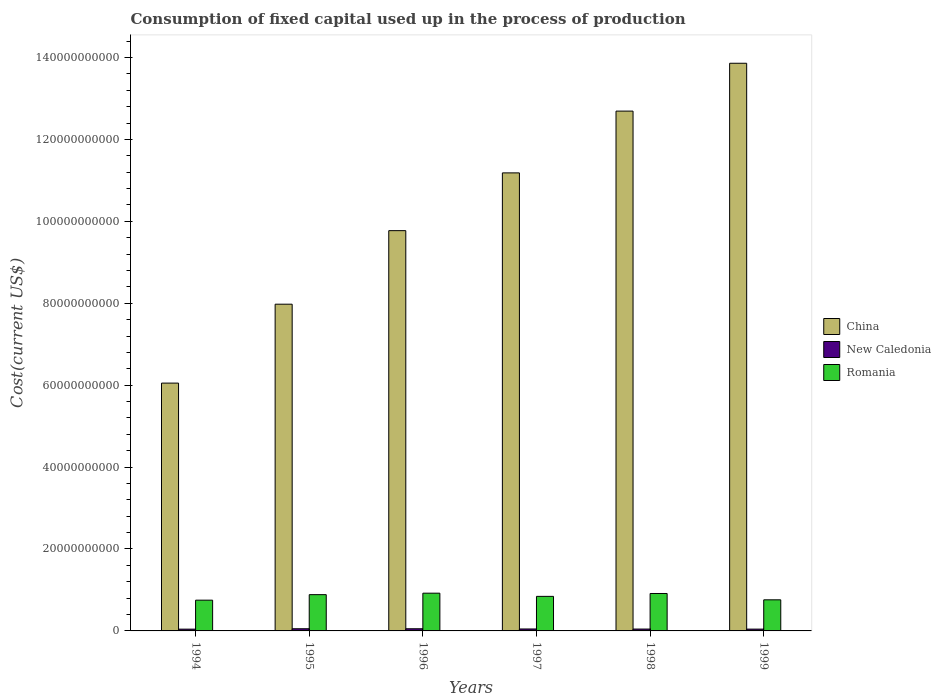How many different coloured bars are there?
Ensure brevity in your answer.  3. Are the number of bars per tick equal to the number of legend labels?
Offer a terse response. Yes. What is the label of the 5th group of bars from the left?
Your answer should be very brief. 1998. What is the amount consumed in the process of production in Romania in 1997?
Your response must be concise. 8.44e+09. Across all years, what is the maximum amount consumed in the process of production in China?
Offer a very short reply. 1.39e+11. Across all years, what is the minimum amount consumed in the process of production in Romania?
Provide a short and direct response. 7.51e+09. What is the total amount consumed in the process of production in Romania in the graph?
Your answer should be compact. 5.07e+1. What is the difference between the amount consumed in the process of production in Romania in 1997 and that in 1998?
Keep it short and to the point. -7.02e+08. What is the difference between the amount consumed in the process of production in New Caledonia in 1997 and the amount consumed in the process of production in China in 1994?
Ensure brevity in your answer.  -6.00e+1. What is the average amount consumed in the process of production in New Caledonia per year?
Offer a terse response. 4.77e+08. In the year 1997, what is the difference between the amount consumed in the process of production in New Caledonia and amount consumed in the process of production in China?
Your answer should be compact. -1.11e+11. In how many years, is the amount consumed in the process of production in New Caledonia greater than 136000000000 US$?
Your response must be concise. 0. What is the ratio of the amount consumed in the process of production in New Caledonia in 1994 to that in 1995?
Your answer should be compact. 0.82. Is the amount consumed in the process of production in China in 1995 less than that in 1997?
Ensure brevity in your answer.  Yes. Is the difference between the amount consumed in the process of production in New Caledonia in 1994 and 1999 greater than the difference between the amount consumed in the process of production in China in 1994 and 1999?
Your answer should be compact. Yes. What is the difference between the highest and the second highest amount consumed in the process of production in New Caledonia?
Ensure brevity in your answer.  3.48e+06. What is the difference between the highest and the lowest amount consumed in the process of production in New Caledonia?
Offer a very short reply. 9.66e+07. In how many years, is the amount consumed in the process of production in Romania greater than the average amount consumed in the process of production in Romania taken over all years?
Your answer should be very brief. 3. Is the sum of the amount consumed in the process of production in New Caledonia in 1995 and 1996 greater than the maximum amount consumed in the process of production in Romania across all years?
Provide a succinct answer. No. What does the 2nd bar from the left in 1996 represents?
Provide a short and direct response. New Caledonia. What does the 1st bar from the right in 1999 represents?
Offer a terse response. Romania. Are all the bars in the graph horizontal?
Give a very brief answer. No. How many years are there in the graph?
Give a very brief answer. 6. Are the values on the major ticks of Y-axis written in scientific E-notation?
Provide a succinct answer. No. Does the graph contain any zero values?
Your answer should be very brief. No. Does the graph contain grids?
Keep it short and to the point. No. How are the legend labels stacked?
Keep it short and to the point. Vertical. What is the title of the graph?
Keep it short and to the point. Consumption of fixed capital used up in the process of production. Does "High income" appear as one of the legend labels in the graph?
Make the answer very short. No. What is the label or title of the Y-axis?
Your response must be concise. Cost(current US$). What is the Cost(current US$) in China in 1994?
Make the answer very short. 6.05e+1. What is the Cost(current US$) of New Caledonia in 1994?
Your response must be concise. 4.34e+08. What is the Cost(current US$) of Romania in 1994?
Make the answer very short. 7.51e+09. What is the Cost(current US$) of China in 1995?
Keep it short and to the point. 7.98e+1. What is the Cost(current US$) of New Caledonia in 1995?
Make the answer very short. 5.31e+08. What is the Cost(current US$) in Romania in 1995?
Make the answer very short. 8.86e+09. What is the Cost(current US$) of China in 1996?
Your answer should be very brief. 9.77e+1. What is the Cost(current US$) in New Caledonia in 1996?
Your response must be concise. 5.27e+08. What is the Cost(current US$) of Romania in 1996?
Ensure brevity in your answer.  9.21e+09. What is the Cost(current US$) of China in 1997?
Your answer should be compact. 1.12e+11. What is the Cost(current US$) of New Caledonia in 1997?
Keep it short and to the point. 4.77e+08. What is the Cost(current US$) in Romania in 1997?
Provide a succinct answer. 8.44e+09. What is the Cost(current US$) of China in 1998?
Give a very brief answer. 1.27e+11. What is the Cost(current US$) in New Caledonia in 1998?
Provide a short and direct response. 4.55e+08. What is the Cost(current US$) in Romania in 1998?
Ensure brevity in your answer.  9.14e+09. What is the Cost(current US$) in China in 1999?
Your response must be concise. 1.39e+11. What is the Cost(current US$) of New Caledonia in 1999?
Your response must be concise. 4.39e+08. What is the Cost(current US$) in Romania in 1999?
Make the answer very short. 7.59e+09. Across all years, what is the maximum Cost(current US$) of China?
Your response must be concise. 1.39e+11. Across all years, what is the maximum Cost(current US$) of New Caledonia?
Your response must be concise. 5.31e+08. Across all years, what is the maximum Cost(current US$) of Romania?
Provide a succinct answer. 9.21e+09. Across all years, what is the minimum Cost(current US$) in China?
Your answer should be very brief. 6.05e+1. Across all years, what is the minimum Cost(current US$) of New Caledonia?
Make the answer very short. 4.34e+08. Across all years, what is the minimum Cost(current US$) in Romania?
Ensure brevity in your answer.  7.51e+09. What is the total Cost(current US$) in China in the graph?
Offer a terse response. 6.15e+11. What is the total Cost(current US$) in New Caledonia in the graph?
Make the answer very short. 2.86e+09. What is the total Cost(current US$) in Romania in the graph?
Offer a terse response. 5.07e+1. What is the difference between the Cost(current US$) of China in 1994 and that in 1995?
Your answer should be compact. -1.93e+1. What is the difference between the Cost(current US$) of New Caledonia in 1994 and that in 1995?
Your answer should be compact. -9.66e+07. What is the difference between the Cost(current US$) of Romania in 1994 and that in 1995?
Your answer should be very brief. -1.35e+09. What is the difference between the Cost(current US$) of China in 1994 and that in 1996?
Provide a succinct answer. -3.72e+1. What is the difference between the Cost(current US$) in New Caledonia in 1994 and that in 1996?
Provide a short and direct response. -9.32e+07. What is the difference between the Cost(current US$) of Romania in 1994 and that in 1996?
Offer a very short reply. -1.70e+09. What is the difference between the Cost(current US$) of China in 1994 and that in 1997?
Provide a succinct answer. -5.13e+1. What is the difference between the Cost(current US$) in New Caledonia in 1994 and that in 1997?
Give a very brief answer. -4.23e+07. What is the difference between the Cost(current US$) in Romania in 1994 and that in 1997?
Ensure brevity in your answer.  -9.27e+08. What is the difference between the Cost(current US$) of China in 1994 and that in 1998?
Offer a very short reply. -6.64e+1. What is the difference between the Cost(current US$) of New Caledonia in 1994 and that in 1998?
Make the answer very short. -2.11e+07. What is the difference between the Cost(current US$) of Romania in 1994 and that in 1998?
Your answer should be compact. -1.63e+09. What is the difference between the Cost(current US$) of China in 1994 and that in 1999?
Your answer should be very brief. -7.81e+1. What is the difference between the Cost(current US$) of New Caledonia in 1994 and that in 1999?
Ensure brevity in your answer.  -4.84e+06. What is the difference between the Cost(current US$) in Romania in 1994 and that in 1999?
Provide a succinct answer. -8.38e+07. What is the difference between the Cost(current US$) of China in 1995 and that in 1996?
Provide a succinct answer. -1.80e+1. What is the difference between the Cost(current US$) of New Caledonia in 1995 and that in 1996?
Your answer should be very brief. 3.48e+06. What is the difference between the Cost(current US$) in Romania in 1995 and that in 1996?
Provide a short and direct response. -3.56e+08. What is the difference between the Cost(current US$) of China in 1995 and that in 1997?
Make the answer very short. -3.21e+1. What is the difference between the Cost(current US$) in New Caledonia in 1995 and that in 1997?
Make the answer very short. 5.43e+07. What is the difference between the Cost(current US$) of Romania in 1995 and that in 1997?
Your answer should be compact. 4.20e+08. What is the difference between the Cost(current US$) in China in 1995 and that in 1998?
Keep it short and to the point. -4.71e+1. What is the difference between the Cost(current US$) of New Caledonia in 1995 and that in 1998?
Give a very brief answer. 7.55e+07. What is the difference between the Cost(current US$) of Romania in 1995 and that in 1998?
Your answer should be compact. -2.81e+08. What is the difference between the Cost(current US$) of China in 1995 and that in 1999?
Offer a terse response. -5.88e+1. What is the difference between the Cost(current US$) in New Caledonia in 1995 and that in 1999?
Keep it short and to the point. 9.18e+07. What is the difference between the Cost(current US$) of Romania in 1995 and that in 1999?
Provide a succinct answer. 1.26e+09. What is the difference between the Cost(current US$) in China in 1996 and that in 1997?
Your answer should be compact. -1.41e+1. What is the difference between the Cost(current US$) of New Caledonia in 1996 and that in 1997?
Keep it short and to the point. 5.08e+07. What is the difference between the Cost(current US$) in Romania in 1996 and that in 1997?
Offer a very short reply. 7.76e+08. What is the difference between the Cost(current US$) in China in 1996 and that in 1998?
Your answer should be very brief. -2.92e+1. What is the difference between the Cost(current US$) in New Caledonia in 1996 and that in 1998?
Make the answer very short. 7.21e+07. What is the difference between the Cost(current US$) of Romania in 1996 and that in 1998?
Ensure brevity in your answer.  7.47e+07. What is the difference between the Cost(current US$) of China in 1996 and that in 1999?
Your answer should be very brief. -4.09e+1. What is the difference between the Cost(current US$) in New Caledonia in 1996 and that in 1999?
Offer a terse response. 8.83e+07. What is the difference between the Cost(current US$) of Romania in 1996 and that in 1999?
Your answer should be compact. 1.62e+09. What is the difference between the Cost(current US$) in China in 1997 and that in 1998?
Offer a very short reply. -1.51e+1. What is the difference between the Cost(current US$) in New Caledonia in 1997 and that in 1998?
Give a very brief answer. 2.12e+07. What is the difference between the Cost(current US$) in Romania in 1997 and that in 1998?
Give a very brief answer. -7.02e+08. What is the difference between the Cost(current US$) in China in 1997 and that in 1999?
Provide a short and direct response. -2.68e+1. What is the difference between the Cost(current US$) of New Caledonia in 1997 and that in 1999?
Your response must be concise. 3.75e+07. What is the difference between the Cost(current US$) in Romania in 1997 and that in 1999?
Ensure brevity in your answer.  8.44e+08. What is the difference between the Cost(current US$) in China in 1998 and that in 1999?
Ensure brevity in your answer.  -1.17e+1. What is the difference between the Cost(current US$) of New Caledonia in 1998 and that in 1999?
Make the answer very short. 1.62e+07. What is the difference between the Cost(current US$) of Romania in 1998 and that in 1999?
Offer a terse response. 1.55e+09. What is the difference between the Cost(current US$) of China in 1994 and the Cost(current US$) of New Caledonia in 1995?
Provide a succinct answer. 6.00e+1. What is the difference between the Cost(current US$) in China in 1994 and the Cost(current US$) in Romania in 1995?
Keep it short and to the point. 5.16e+1. What is the difference between the Cost(current US$) of New Caledonia in 1994 and the Cost(current US$) of Romania in 1995?
Your answer should be compact. -8.42e+09. What is the difference between the Cost(current US$) in China in 1994 and the Cost(current US$) in New Caledonia in 1996?
Offer a terse response. 6.00e+1. What is the difference between the Cost(current US$) of China in 1994 and the Cost(current US$) of Romania in 1996?
Provide a succinct answer. 5.13e+1. What is the difference between the Cost(current US$) in New Caledonia in 1994 and the Cost(current US$) in Romania in 1996?
Offer a very short reply. -8.78e+09. What is the difference between the Cost(current US$) of China in 1994 and the Cost(current US$) of New Caledonia in 1997?
Your answer should be very brief. 6.00e+1. What is the difference between the Cost(current US$) of China in 1994 and the Cost(current US$) of Romania in 1997?
Offer a terse response. 5.21e+1. What is the difference between the Cost(current US$) in New Caledonia in 1994 and the Cost(current US$) in Romania in 1997?
Provide a succinct answer. -8.00e+09. What is the difference between the Cost(current US$) in China in 1994 and the Cost(current US$) in New Caledonia in 1998?
Make the answer very short. 6.00e+1. What is the difference between the Cost(current US$) of China in 1994 and the Cost(current US$) of Romania in 1998?
Your answer should be very brief. 5.14e+1. What is the difference between the Cost(current US$) of New Caledonia in 1994 and the Cost(current US$) of Romania in 1998?
Your answer should be compact. -8.70e+09. What is the difference between the Cost(current US$) in China in 1994 and the Cost(current US$) in New Caledonia in 1999?
Your answer should be compact. 6.01e+1. What is the difference between the Cost(current US$) in China in 1994 and the Cost(current US$) in Romania in 1999?
Give a very brief answer. 5.29e+1. What is the difference between the Cost(current US$) in New Caledonia in 1994 and the Cost(current US$) in Romania in 1999?
Ensure brevity in your answer.  -7.16e+09. What is the difference between the Cost(current US$) in China in 1995 and the Cost(current US$) in New Caledonia in 1996?
Make the answer very short. 7.92e+1. What is the difference between the Cost(current US$) of China in 1995 and the Cost(current US$) of Romania in 1996?
Make the answer very short. 7.06e+1. What is the difference between the Cost(current US$) in New Caledonia in 1995 and the Cost(current US$) in Romania in 1996?
Offer a terse response. -8.68e+09. What is the difference between the Cost(current US$) in China in 1995 and the Cost(current US$) in New Caledonia in 1997?
Keep it short and to the point. 7.93e+1. What is the difference between the Cost(current US$) in China in 1995 and the Cost(current US$) in Romania in 1997?
Keep it short and to the point. 7.13e+1. What is the difference between the Cost(current US$) of New Caledonia in 1995 and the Cost(current US$) of Romania in 1997?
Provide a short and direct response. -7.91e+09. What is the difference between the Cost(current US$) of China in 1995 and the Cost(current US$) of New Caledonia in 1998?
Your response must be concise. 7.93e+1. What is the difference between the Cost(current US$) of China in 1995 and the Cost(current US$) of Romania in 1998?
Make the answer very short. 7.06e+1. What is the difference between the Cost(current US$) of New Caledonia in 1995 and the Cost(current US$) of Romania in 1998?
Offer a terse response. -8.61e+09. What is the difference between the Cost(current US$) in China in 1995 and the Cost(current US$) in New Caledonia in 1999?
Offer a very short reply. 7.93e+1. What is the difference between the Cost(current US$) in China in 1995 and the Cost(current US$) in Romania in 1999?
Offer a very short reply. 7.22e+1. What is the difference between the Cost(current US$) in New Caledonia in 1995 and the Cost(current US$) in Romania in 1999?
Your response must be concise. -7.06e+09. What is the difference between the Cost(current US$) in China in 1996 and the Cost(current US$) in New Caledonia in 1997?
Your answer should be very brief. 9.72e+1. What is the difference between the Cost(current US$) of China in 1996 and the Cost(current US$) of Romania in 1997?
Give a very brief answer. 8.93e+1. What is the difference between the Cost(current US$) in New Caledonia in 1996 and the Cost(current US$) in Romania in 1997?
Ensure brevity in your answer.  -7.91e+09. What is the difference between the Cost(current US$) of China in 1996 and the Cost(current US$) of New Caledonia in 1998?
Provide a short and direct response. 9.73e+1. What is the difference between the Cost(current US$) in China in 1996 and the Cost(current US$) in Romania in 1998?
Offer a terse response. 8.86e+1. What is the difference between the Cost(current US$) of New Caledonia in 1996 and the Cost(current US$) of Romania in 1998?
Keep it short and to the point. -8.61e+09. What is the difference between the Cost(current US$) of China in 1996 and the Cost(current US$) of New Caledonia in 1999?
Provide a short and direct response. 9.73e+1. What is the difference between the Cost(current US$) of China in 1996 and the Cost(current US$) of Romania in 1999?
Ensure brevity in your answer.  9.01e+1. What is the difference between the Cost(current US$) in New Caledonia in 1996 and the Cost(current US$) in Romania in 1999?
Provide a short and direct response. -7.07e+09. What is the difference between the Cost(current US$) in China in 1997 and the Cost(current US$) in New Caledonia in 1998?
Offer a terse response. 1.11e+11. What is the difference between the Cost(current US$) of China in 1997 and the Cost(current US$) of Romania in 1998?
Give a very brief answer. 1.03e+11. What is the difference between the Cost(current US$) in New Caledonia in 1997 and the Cost(current US$) in Romania in 1998?
Your answer should be compact. -8.66e+09. What is the difference between the Cost(current US$) of China in 1997 and the Cost(current US$) of New Caledonia in 1999?
Ensure brevity in your answer.  1.11e+11. What is the difference between the Cost(current US$) of China in 1997 and the Cost(current US$) of Romania in 1999?
Give a very brief answer. 1.04e+11. What is the difference between the Cost(current US$) of New Caledonia in 1997 and the Cost(current US$) of Romania in 1999?
Your answer should be very brief. -7.12e+09. What is the difference between the Cost(current US$) of China in 1998 and the Cost(current US$) of New Caledonia in 1999?
Provide a short and direct response. 1.26e+11. What is the difference between the Cost(current US$) of China in 1998 and the Cost(current US$) of Romania in 1999?
Your answer should be very brief. 1.19e+11. What is the difference between the Cost(current US$) in New Caledonia in 1998 and the Cost(current US$) in Romania in 1999?
Give a very brief answer. -7.14e+09. What is the average Cost(current US$) of China per year?
Ensure brevity in your answer.  1.03e+11. What is the average Cost(current US$) in New Caledonia per year?
Keep it short and to the point. 4.77e+08. What is the average Cost(current US$) of Romania per year?
Ensure brevity in your answer.  8.46e+09. In the year 1994, what is the difference between the Cost(current US$) of China and Cost(current US$) of New Caledonia?
Your answer should be very brief. 6.01e+1. In the year 1994, what is the difference between the Cost(current US$) of China and Cost(current US$) of Romania?
Provide a succinct answer. 5.30e+1. In the year 1994, what is the difference between the Cost(current US$) of New Caledonia and Cost(current US$) of Romania?
Provide a succinct answer. -7.08e+09. In the year 1995, what is the difference between the Cost(current US$) in China and Cost(current US$) in New Caledonia?
Your answer should be very brief. 7.92e+1. In the year 1995, what is the difference between the Cost(current US$) of China and Cost(current US$) of Romania?
Provide a short and direct response. 7.09e+1. In the year 1995, what is the difference between the Cost(current US$) of New Caledonia and Cost(current US$) of Romania?
Provide a succinct answer. -8.33e+09. In the year 1996, what is the difference between the Cost(current US$) in China and Cost(current US$) in New Caledonia?
Your response must be concise. 9.72e+1. In the year 1996, what is the difference between the Cost(current US$) in China and Cost(current US$) in Romania?
Make the answer very short. 8.85e+1. In the year 1996, what is the difference between the Cost(current US$) in New Caledonia and Cost(current US$) in Romania?
Keep it short and to the point. -8.69e+09. In the year 1997, what is the difference between the Cost(current US$) in China and Cost(current US$) in New Caledonia?
Give a very brief answer. 1.11e+11. In the year 1997, what is the difference between the Cost(current US$) in China and Cost(current US$) in Romania?
Your answer should be very brief. 1.03e+11. In the year 1997, what is the difference between the Cost(current US$) in New Caledonia and Cost(current US$) in Romania?
Your answer should be very brief. -7.96e+09. In the year 1998, what is the difference between the Cost(current US$) in China and Cost(current US$) in New Caledonia?
Your answer should be very brief. 1.26e+11. In the year 1998, what is the difference between the Cost(current US$) of China and Cost(current US$) of Romania?
Provide a succinct answer. 1.18e+11. In the year 1998, what is the difference between the Cost(current US$) of New Caledonia and Cost(current US$) of Romania?
Your response must be concise. -8.68e+09. In the year 1999, what is the difference between the Cost(current US$) in China and Cost(current US$) in New Caledonia?
Make the answer very short. 1.38e+11. In the year 1999, what is the difference between the Cost(current US$) in China and Cost(current US$) in Romania?
Your response must be concise. 1.31e+11. In the year 1999, what is the difference between the Cost(current US$) of New Caledonia and Cost(current US$) of Romania?
Give a very brief answer. -7.15e+09. What is the ratio of the Cost(current US$) of China in 1994 to that in 1995?
Keep it short and to the point. 0.76. What is the ratio of the Cost(current US$) in New Caledonia in 1994 to that in 1995?
Make the answer very short. 0.82. What is the ratio of the Cost(current US$) of Romania in 1994 to that in 1995?
Offer a terse response. 0.85. What is the ratio of the Cost(current US$) in China in 1994 to that in 1996?
Your response must be concise. 0.62. What is the ratio of the Cost(current US$) of New Caledonia in 1994 to that in 1996?
Give a very brief answer. 0.82. What is the ratio of the Cost(current US$) in Romania in 1994 to that in 1996?
Keep it short and to the point. 0.82. What is the ratio of the Cost(current US$) of China in 1994 to that in 1997?
Your response must be concise. 0.54. What is the ratio of the Cost(current US$) of New Caledonia in 1994 to that in 1997?
Give a very brief answer. 0.91. What is the ratio of the Cost(current US$) in Romania in 1994 to that in 1997?
Ensure brevity in your answer.  0.89. What is the ratio of the Cost(current US$) in China in 1994 to that in 1998?
Ensure brevity in your answer.  0.48. What is the ratio of the Cost(current US$) of New Caledonia in 1994 to that in 1998?
Your answer should be compact. 0.95. What is the ratio of the Cost(current US$) of Romania in 1994 to that in 1998?
Provide a succinct answer. 0.82. What is the ratio of the Cost(current US$) in China in 1994 to that in 1999?
Your answer should be very brief. 0.44. What is the ratio of the Cost(current US$) of Romania in 1994 to that in 1999?
Ensure brevity in your answer.  0.99. What is the ratio of the Cost(current US$) in China in 1995 to that in 1996?
Ensure brevity in your answer.  0.82. What is the ratio of the Cost(current US$) of New Caledonia in 1995 to that in 1996?
Provide a succinct answer. 1.01. What is the ratio of the Cost(current US$) of Romania in 1995 to that in 1996?
Keep it short and to the point. 0.96. What is the ratio of the Cost(current US$) of China in 1995 to that in 1997?
Make the answer very short. 0.71. What is the ratio of the Cost(current US$) of New Caledonia in 1995 to that in 1997?
Ensure brevity in your answer.  1.11. What is the ratio of the Cost(current US$) in Romania in 1995 to that in 1997?
Your response must be concise. 1.05. What is the ratio of the Cost(current US$) in China in 1995 to that in 1998?
Give a very brief answer. 0.63. What is the ratio of the Cost(current US$) in New Caledonia in 1995 to that in 1998?
Keep it short and to the point. 1.17. What is the ratio of the Cost(current US$) of Romania in 1995 to that in 1998?
Make the answer very short. 0.97. What is the ratio of the Cost(current US$) in China in 1995 to that in 1999?
Provide a short and direct response. 0.58. What is the ratio of the Cost(current US$) in New Caledonia in 1995 to that in 1999?
Provide a succinct answer. 1.21. What is the ratio of the Cost(current US$) of Romania in 1995 to that in 1999?
Offer a very short reply. 1.17. What is the ratio of the Cost(current US$) in China in 1996 to that in 1997?
Your answer should be compact. 0.87. What is the ratio of the Cost(current US$) of New Caledonia in 1996 to that in 1997?
Keep it short and to the point. 1.11. What is the ratio of the Cost(current US$) of Romania in 1996 to that in 1997?
Your answer should be compact. 1.09. What is the ratio of the Cost(current US$) in China in 1996 to that in 1998?
Your response must be concise. 0.77. What is the ratio of the Cost(current US$) of New Caledonia in 1996 to that in 1998?
Your response must be concise. 1.16. What is the ratio of the Cost(current US$) of Romania in 1996 to that in 1998?
Give a very brief answer. 1.01. What is the ratio of the Cost(current US$) in China in 1996 to that in 1999?
Offer a terse response. 0.71. What is the ratio of the Cost(current US$) in New Caledonia in 1996 to that in 1999?
Your answer should be compact. 1.2. What is the ratio of the Cost(current US$) of Romania in 1996 to that in 1999?
Ensure brevity in your answer.  1.21. What is the ratio of the Cost(current US$) in China in 1997 to that in 1998?
Make the answer very short. 0.88. What is the ratio of the Cost(current US$) of New Caledonia in 1997 to that in 1998?
Your response must be concise. 1.05. What is the ratio of the Cost(current US$) in Romania in 1997 to that in 1998?
Your answer should be compact. 0.92. What is the ratio of the Cost(current US$) in China in 1997 to that in 1999?
Your answer should be very brief. 0.81. What is the ratio of the Cost(current US$) of New Caledonia in 1997 to that in 1999?
Give a very brief answer. 1.09. What is the ratio of the Cost(current US$) in Romania in 1997 to that in 1999?
Ensure brevity in your answer.  1.11. What is the ratio of the Cost(current US$) of China in 1998 to that in 1999?
Your answer should be compact. 0.92. What is the ratio of the Cost(current US$) of New Caledonia in 1998 to that in 1999?
Offer a very short reply. 1.04. What is the ratio of the Cost(current US$) of Romania in 1998 to that in 1999?
Your response must be concise. 1.2. What is the difference between the highest and the second highest Cost(current US$) of China?
Ensure brevity in your answer.  1.17e+1. What is the difference between the highest and the second highest Cost(current US$) in New Caledonia?
Offer a terse response. 3.48e+06. What is the difference between the highest and the second highest Cost(current US$) in Romania?
Offer a terse response. 7.47e+07. What is the difference between the highest and the lowest Cost(current US$) of China?
Give a very brief answer. 7.81e+1. What is the difference between the highest and the lowest Cost(current US$) of New Caledonia?
Give a very brief answer. 9.66e+07. What is the difference between the highest and the lowest Cost(current US$) of Romania?
Ensure brevity in your answer.  1.70e+09. 